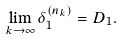<formula> <loc_0><loc_0><loc_500><loc_500>\lim _ { k \rightarrow \infty } \delta _ { 1 } ^ { ( n _ { k } ) } = D _ { 1 } .</formula> 